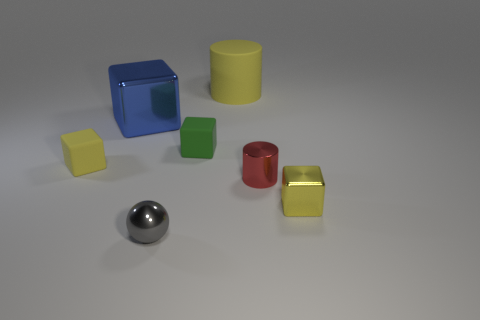Add 3 brown rubber objects. How many objects exist? 10 Subtract all tiny green rubber cubes. How many cubes are left? 3 Subtract all gray balls. How many yellow blocks are left? 2 Subtract all cylinders. How many objects are left? 5 Subtract all small matte blocks. Subtract all big blocks. How many objects are left? 4 Add 3 blue metallic blocks. How many blue metallic blocks are left? 4 Add 7 yellow rubber blocks. How many yellow rubber blocks exist? 8 Subtract all yellow cylinders. How many cylinders are left? 1 Subtract 0 cyan cylinders. How many objects are left? 7 Subtract 4 cubes. How many cubes are left? 0 